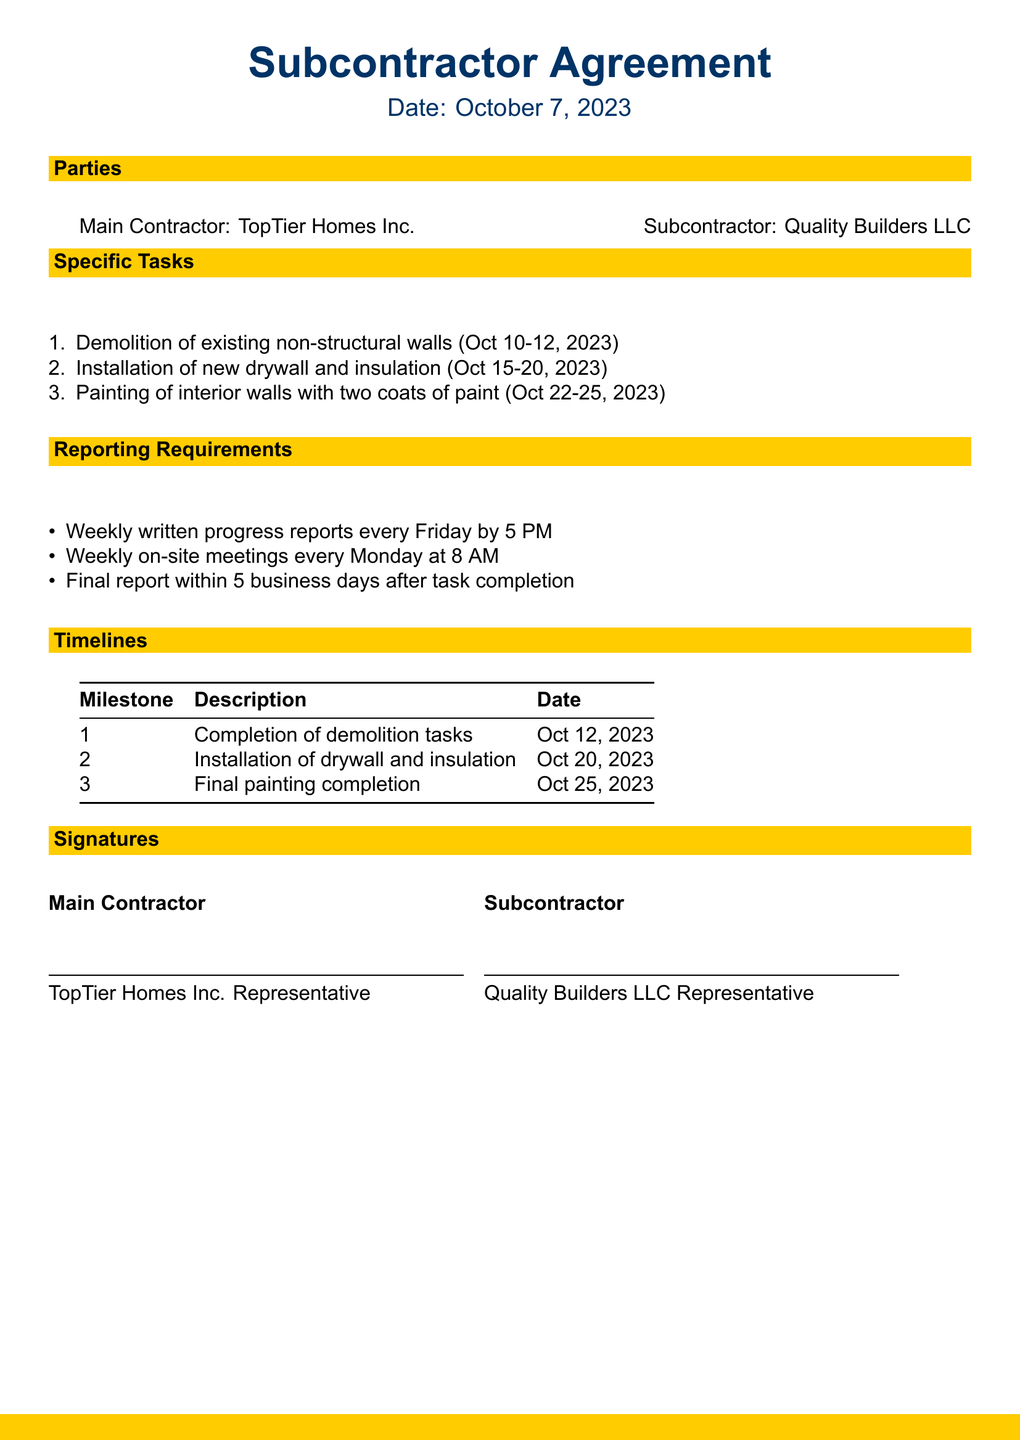what is the name of the main contractor? The main contractor is identified in the document as "TopTier Homes Inc."
Answer: TopTier Homes Inc who is the subcontractor? The document specifies the subcontractor's name as "Quality Builders LLC."
Answer: Quality Builders LLC what task is scheduled from October 15 to 20, 2023? The document lists the scheduled task during this timeframe as "Installation of new drywall and insulation."
Answer: Installation of new drywall and insulation when is the final painting completion date? The completion date for the final painting task is provided in the document as "Oct 25, 2023."
Answer: Oct 25, 2023 how often are written progress reports required? The document states the frequency of progress reports as "Weekly."
Answer: Weekly what is the deadline for the final report after task completion? The final report deadline is outlined as "within 5 business days after task completion."
Answer: within 5 business days how many coats of paint are specified for the painting task? The painting task requires "two coats of paint" as mentioned in the document.
Answer: two coats of paint what time is the weekly on-site meeting scheduled? The document specifies that the weekly on-site meetings are scheduled for "8 AM."
Answer: 8 AM what is the milestone for the completion of demolition tasks? The milestone description is listed as "Completion of demolition tasks."
Answer: Completion of demolition tasks 